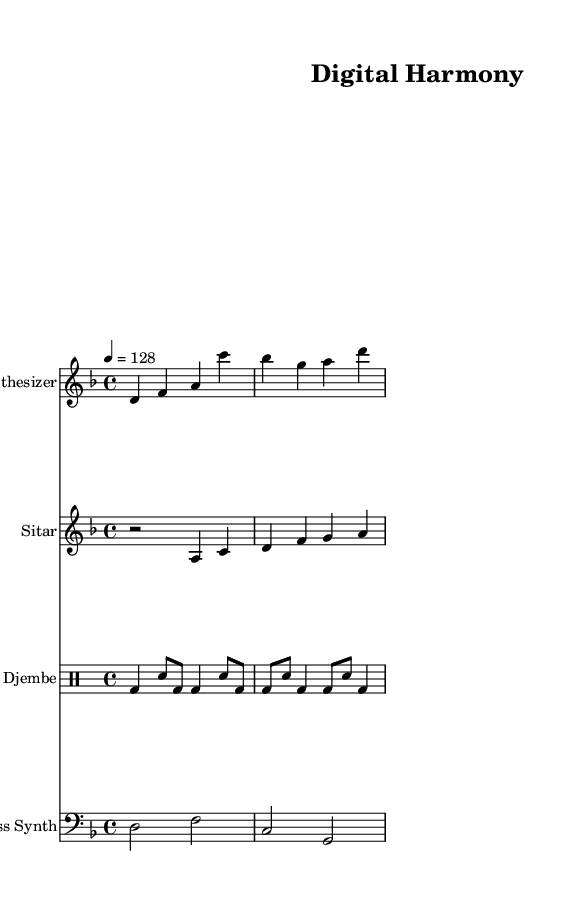What is the key signature of this music? The key signature is D minor, which contains one flat (B flat) and indicates that the piece is centered around the D minor scale.
Answer: D minor What is the time signature of this music? The time signature is 4/4, which means there are four beats in each measure, and the quarter note gets one beat.
Answer: 4/4 What is the tempo marking indicated in the score? The tempo marking is 4 = 128, indicating a metronome marking of 128 beats per minute, setting a lively pace for the piece.
Answer: 128 How many different instruments are featured in this piece? There are four instruments: Synthesizer, Sitar, Djembe, and Bass Synth, which contribute to the fusion style of the music.
Answer: Four Which instrument plays a counter melody? The Sitar plays a counter melody, which adds a distinct cultural element to the techno fusion style, complementing the main melody.
Answer: Sitar What rhythmic pattern does the Djembe use in the first two measures? The Djembe uses a bass-drum (bd) followed by snare (sn) pattern, alternating between different note durations that create a driving rhythm, typical for a techno influence.
Answer: Bass-drum and snare pattern What genre does this piece celebrate through its instrumentation and composition? This piece celebrates the fusion of techno-world music, as indicated by the combination of electronic instrumentation like the synthesizer and traditional elements like the sitar to convey global connectivity.
Answer: Techno-world music fusion 